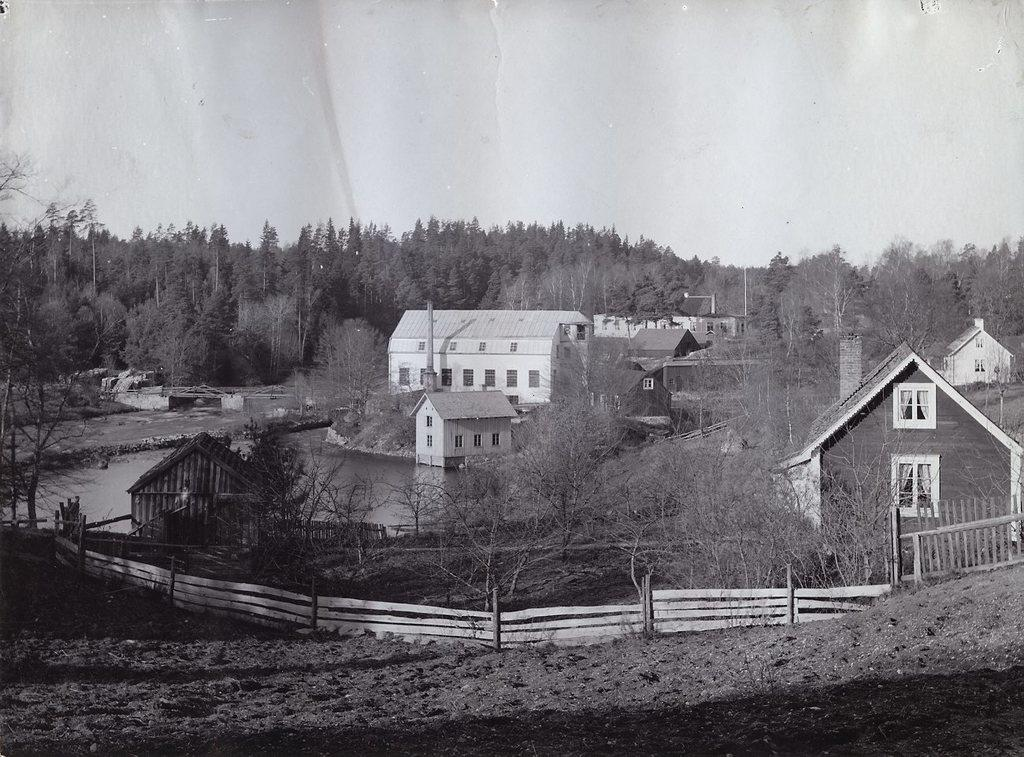What is the color scheme of the image? The image is black and white. What can be seen in the center of the image? There are houses in the center of the image. What type of natural elements are visible in the background of the image? There are trees in the background of the image. What type of pancake is being served at the house in the image? There is no pancake visible in the image, as it is a black and white image of houses and trees. 